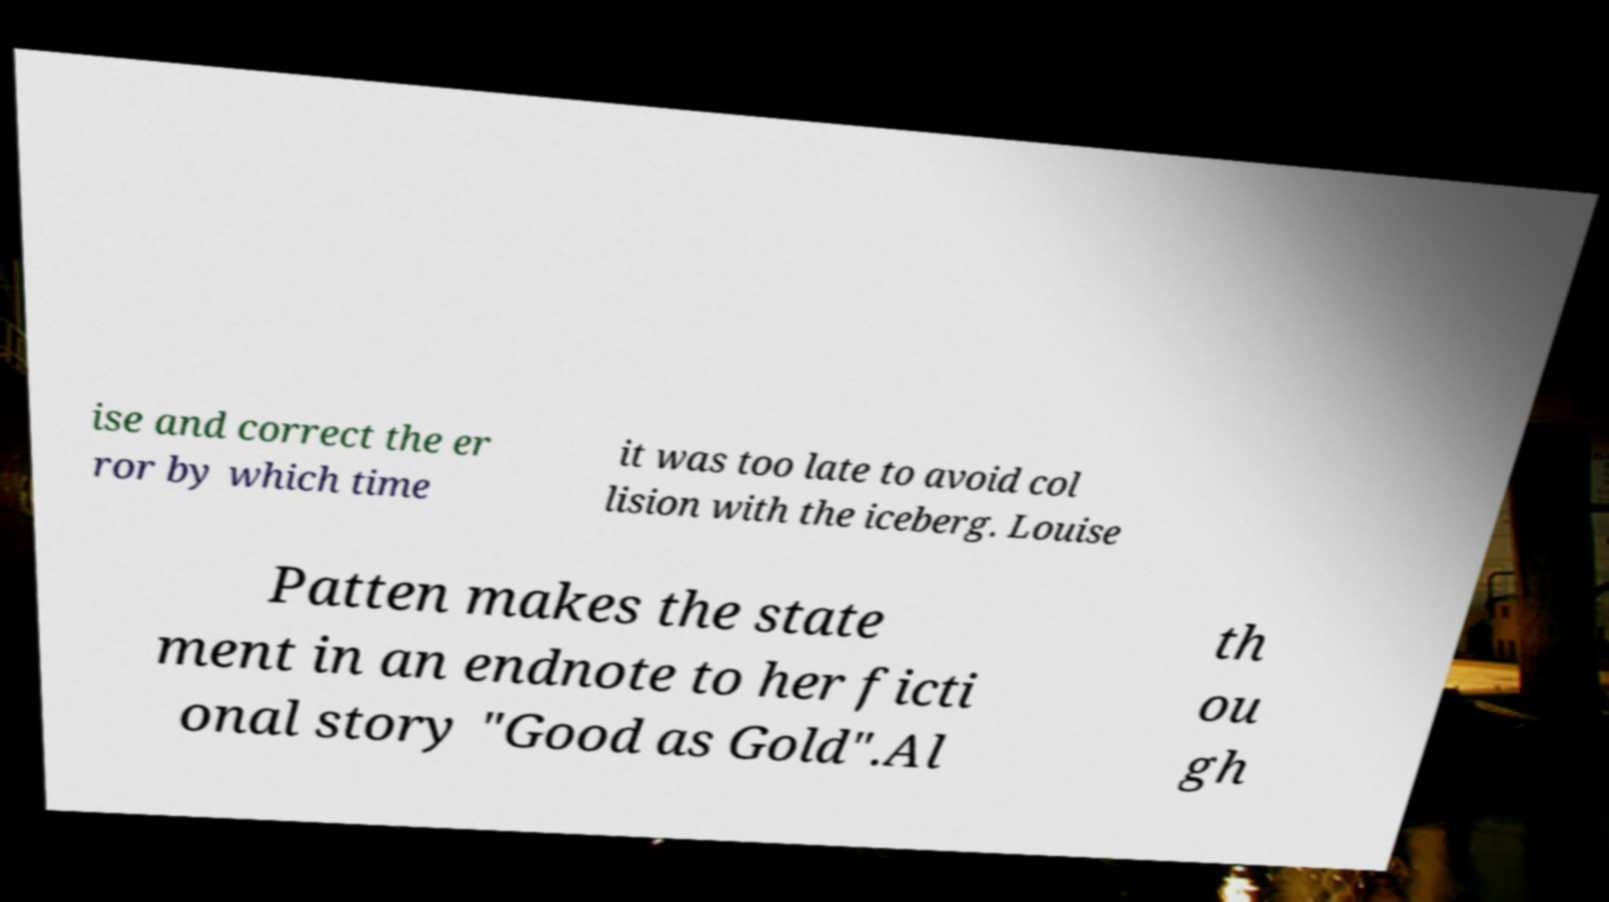There's text embedded in this image that I need extracted. Can you transcribe it verbatim? ise and correct the er ror by which time it was too late to avoid col lision with the iceberg. Louise Patten makes the state ment in an endnote to her ficti onal story "Good as Gold".Al th ou gh 